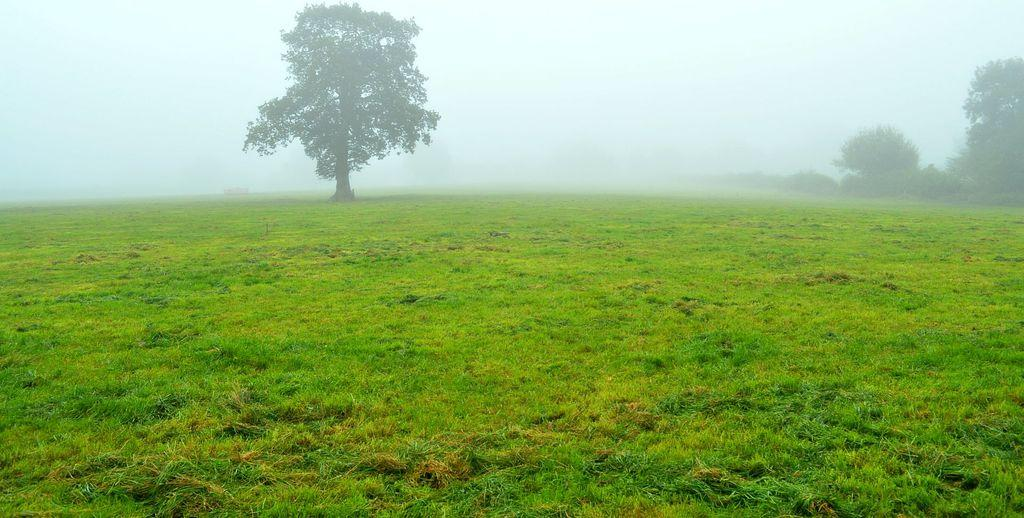What type of vegetation can be seen in the image? There are trees in the image. What is the color of the grass in the image? The grass in the image is green. What colors are present in the sky in the image? The sky is blue and white in color. How many apples are hanging from the trees in the image? There are no apples present in the image; only trees are visible. What type of wheel can be seen in the image? There is no wheel present in the image. 